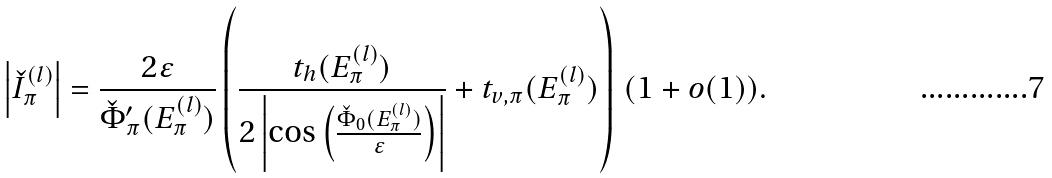Convert formula to latex. <formula><loc_0><loc_0><loc_500><loc_500>\left | \check { I } _ { \pi } ^ { ( l ) } \right | = \frac { 2 \varepsilon } { \check { \Phi } _ { \pi } ^ { \prime } ( E _ { \pi } ^ { ( l ) } ) } \left ( \frac { t _ { h } ( E _ { \pi } ^ { ( l ) } ) } { 2 \left | \cos \left ( \frac { \check { \Phi } _ { 0 } ( E _ { \pi } ^ { ( l ) } ) } { \varepsilon } \right ) \right | } + t _ { v , \pi } ( E _ { \pi } ^ { ( l ) } ) \right ) \, ( 1 + o ( 1 ) ) .</formula> 